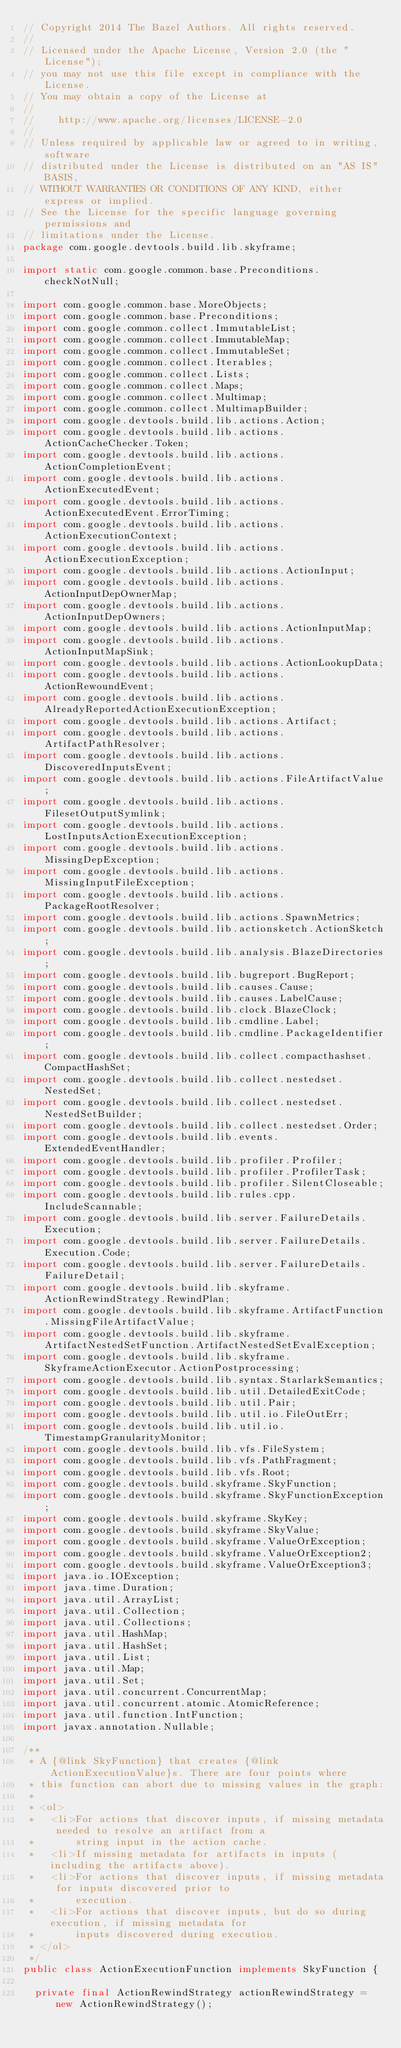Convert code to text. <code><loc_0><loc_0><loc_500><loc_500><_Java_>// Copyright 2014 The Bazel Authors. All rights reserved.
//
// Licensed under the Apache License, Version 2.0 (the "License");
// you may not use this file except in compliance with the License.
// You may obtain a copy of the License at
//
//    http://www.apache.org/licenses/LICENSE-2.0
//
// Unless required by applicable law or agreed to in writing, software
// distributed under the License is distributed on an "AS IS" BASIS,
// WITHOUT WARRANTIES OR CONDITIONS OF ANY KIND, either express or implied.
// See the License for the specific language governing permissions and
// limitations under the License.
package com.google.devtools.build.lib.skyframe;

import static com.google.common.base.Preconditions.checkNotNull;

import com.google.common.base.MoreObjects;
import com.google.common.base.Preconditions;
import com.google.common.collect.ImmutableList;
import com.google.common.collect.ImmutableMap;
import com.google.common.collect.ImmutableSet;
import com.google.common.collect.Iterables;
import com.google.common.collect.Lists;
import com.google.common.collect.Maps;
import com.google.common.collect.Multimap;
import com.google.common.collect.MultimapBuilder;
import com.google.devtools.build.lib.actions.Action;
import com.google.devtools.build.lib.actions.ActionCacheChecker.Token;
import com.google.devtools.build.lib.actions.ActionCompletionEvent;
import com.google.devtools.build.lib.actions.ActionExecutedEvent;
import com.google.devtools.build.lib.actions.ActionExecutedEvent.ErrorTiming;
import com.google.devtools.build.lib.actions.ActionExecutionContext;
import com.google.devtools.build.lib.actions.ActionExecutionException;
import com.google.devtools.build.lib.actions.ActionInput;
import com.google.devtools.build.lib.actions.ActionInputDepOwnerMap;
import com.google.devtools.build.lib.actions.ActionInputDepOwners;
import com.google.devtools.build.lib.actions.ActionInputMap;
import com.google.devtools.build.lib.actions.ActionInputMapSink;
import com.google.devtools.build.lib.actions.ActionLookupData;
import com.google.devtools.build.lib.actions.ActionRewoundEvent;
import com.google.devtools.build.lib.actions.AlreadyReportedActionExecutionException;
import com.google.devtools.build.lib.actions.Artifact;
import com.google.devtools.build.lib.actions.ArtifactPathResolver;
import com.google.devtools.build.lib.actions.DiscoveredInputsEvent;
import com.google.devtools.build.lib.actions.FileArtifactValue;
import com.google.devtools.build.lib.actions.FilesetOutputSymlink;
import com.google.devtools.build.lib.actions.LostInputsActionExecutionException;
import com.google.devtools.build.lib.actions.MissingDepException;
import com.google.devtools.build.lib.actions.MissingInputFileException;
import com.google.devtools.build.lib.actions.PackageRootResolver;
import com.google.devtools.build.lib.actions.SpawnMetrics;
import com.google.devtools.build.lib.actionsketch.ActionSketch;
import com.google.devtools.build.lib.analysis.BlazeDirectories;
import com.google.devtools.build.lib.bugreport.BugReport;
import com.google.devtools.build.lib.causes.Cause;
import com.google.devtools.build.lib.causes.LabelCause;
import com.google.devtools.build.lib.clock.BlazeClock;
import com.google.devtools.build.lib.cmdline.Label;
import com.google.devtools.build.lib.cmdline.PackageIdentifier;
import com.google.devtools.build.lib.collect.compacthashset.CompactHashSet;
import com.google.devtools.build.lib.collect.nestedset.NestedSet;
import com.google.devtools.build.lib.collect.nestedset.NestedSetBuilder;
import com.google.devtools.build.lib.collect.nestedset.Order;
import com.google.devtools.build.lib.events.ExtendedEventHandler;
import com.google.devtools.build.lib.profiler.Profiler;
import com.google.devtools.build.lib.profiler.ProfilerTask;
import com.google.devtools.build.lib.profiler.SilentCloseable;
import com.google.devtools.build.lib.rules.cpp.IncludeScannable;
import com.google.devtools.build.lib.server.FailureDetails.Execution;
import com.google.devtools.build.lib.server.FailureDetails.Execution.Code;
import com.google.devtools.build.lib.server.FailureDetails.FailureDetail;
import com.google.devtools.build.lib.skyframe.ActionRewindStrategy.RewindPlan;
import com.google.devtools.build.lib.skyframe.ArtifactFunction.MissingFileArtifactValue;
import com.google.devtools.build.lib.skyframe.ArtifactNestedSetFunction.ArtifactNestedSetEvalException;
import com.google.devtools.build.lib.skyframe.SkyframeActionExecutor.ActionPostprocessing;
import com.google.devtools.build.lib.syntax.StarlarkSemantics;
import com.google.devtools.build.lib.util.DetailedExitCode;
import com.google.devtools.build.lib.util.Pair;
import com.google.devtools.build.lib.util.io.FileOutErr;
import com.google.devtools.build.lib.util.io.TimestampGranularityMonitor;
import com.google.devtools.build.lib.vfs.FileSystem;
import com.google.devtools.build.lib.vfs.PathFragment;
import com.google.devtools.build.lib.vfs.Root;
import com.google.devtools.build.skyframe.SkyFunction;
import com.google.devtools.build.skyframe.SkyFunctionException;
import com.google.devtools.build.skyframe.SkyKey;
import com.google.devtools.build.skyframe.SkyValue;
import com.google.devtools.build.skyframe.ValueOrException;
import com.google.devtools.build.skyframe.ValueOrException2;
import com.google.devtools.build.skyframe.ValueOrException3;
import java.io.IOException;
import java.time.Duration;
import java.util.ArrayList;
import java.util.Collection;
import java.util.Collections;
import java.util.HashMap;
import java.util.HashSet;
import java.util.List;
import java.util.Map;
import java.util.Set;
import java.util.concurrent.ConcurrentMap;
import java.util.concurrent.atomic.AtomicReference;
import java.util.function.IntFunction;
import javax.annotation.Nullable;

/**
 * A {@link SkyFunction} that creates {@link ActionExecutionValue}s. There are four points where
 * this function can abort due to missing values in the graph:
 *
 * <ol>
 *   <li>For actions that discover inputs, if missing metadata needed to resolve an artifact from a
 *       string input in the action cache.
 *   <li>If missing metadata for artifacts in inputs (including the artifacts above).
 *   <li>For actions that discover inputs, if missing metadata for inputs discovered prior to
 *       execution.
 *   <li>For actions that discover inputs, but do so during execution, if missing metadata for
 *       inputs discovered during execution.
 * </ol>
 */
public class ActionExecutionFunction implements SkyFunction {

  private final ActionRewindStrategy actionRewindStrategy = new ActionRewindStrategy();</code> 